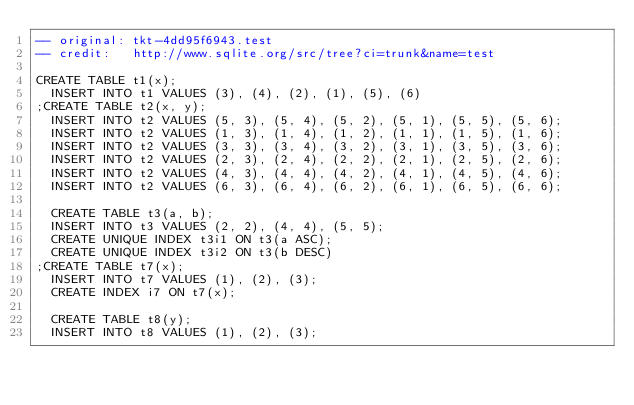<code> <loc_0><loc_0><loc_500><loc_500><_SQL_>-- original: tkt-4dd95f6943.test
-- credit:   http://www.sqlite.org/src/tree?ci=trunk&name=test

CREATE TABLE t1(x);
  INSERT INTO t1 VALUES (3), (4), (2), (1), (5), (6)
;CREATE TABLE t2(x, y);
  INSERT INTO t2 VALUES (5, 3), (5, 4), (5, 2), (5, 1), (5, 5), (5, 6);
  INSERT INTO t2 VALUES (1, 3), (1, 4), (1, 2), (1, 1), (1, 5), (1, 6);
  INSERT INTO t2 VALUES (3, 3), (3, 4), (3, 2), (3, 1), (3, 5), (3, 6);
  INSERT INTO t2 VALUES (2, 3), (2, 4), (2, 2), (2, 1), (2, 5), (2, 6);
  INSERT INTO t2 VALUES (4, 3), (4, 4), (4, 2), (4, 1), (4, 5), (4, 6);
  INSERT INTO t2 VALUES (6, 3), (6, 4), (6, 2), (6, 1), (6, 5), (6, 6);

  CREATE TABLE t3(a, b);
  INSERT INTO t3 VALUES (2, 2), (4, 4), (5, 5);
  CREATE UNIQUE INDEX t3i1 ON t3(a ASC);
  CREATE UNIQUE INDEX t3i2 ON t3(b DESC)
;CREATE TABLE t7(x);
  INSERT INTO t7 VALUES (1), (2), (3);
  CREATE INDEX i7 ON t7(x);

  CREATE TABLE t8(y);
  INSERT INTO t8 VALUES (1), (2), (3);</code> 